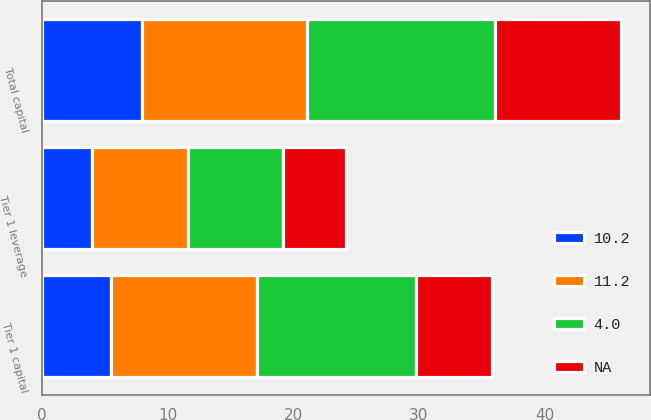Convert chart to OTSL. <chart><loc_0><loc_0><loc_500><loc_500><stacked_bar_chart><ecel><fcel>Tier 1 capital<fcel>Total capital<fcel>Tier 1 leverage<nl><fcel>4<fcel>12.7<fcel>15<fcel>7.6<nl><fcel>11.2<fcel>11.6<fcel>13.1<fcel>7.6<nl><fcel>10.2<fcel>5.5<fcel>8<fcel>4<nl><fcel>nan<fcel>6<fcel>10<fcel>5<nl></chart> 